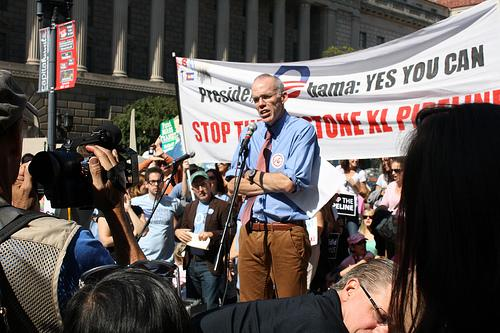Identify the person who is giving a speech and what they are wearing. The man giving a speech is wearing a blue dress shirt, brown pants, a reddish-pink tie, and eyeglasses. What is a noteworthy aspect of the man's body language? The man's body language suggests that he is closed off, maybe nervous or defensive while giving the speech. Discuss any flags or banners present in the image, and their colors. There is a pole with two pennants; one is red, and the other is grey. Additionally, there's a political banner behind the man, which is white with red letters. Describe the scene involving the man campaigning for Obama. There is a man campaigning for Obama, giving a speech, and standing in front of a political banner with a white sign with red letters. The man is wearing glasses, a blue dress shirt, and brown pants. What is the man in the foreground doing, and how is his outfit described? The man in the foreground is giving a speech, and he is wearing eyeglasses, a blue dress shirt with rolled-up sleeves, a reddish-pink tie, brown pants, and a brown belt. Mention the salient features of the building in the background. The large building in the background has lots of columns and appears to be an important or historical venue. List the elements on the pole in the image. Two pennants, one red and the other grey, are hanging on the pole. Develop a title for an article featuring a man giving a speech in front of a crowd at a campaign event. "Electrifying Speech Captivates Audience at Campaign Rally: A Moment to Remember" Identify the color of the tie the man is wearing. Reddishpink Assess the emotion displayed by the man giving the speech. The man appears confident and focused as he speaks. Choose the correct event from the given options: A wedding, A political rally, A sports game. A political rally What is happening in the scene depicted in the image? A man is giving a speech during a campaign event with people surrounding him. Articulate the style of the hat worn by the man in the background. The hat is a green cap with a round, dome-shaped crown and a visor. State the color of the dress shirt worn by the man giving the speech. Blue What is the man doing in the image? The man is giving a speech. Provide a detailed description of the microphone setup used by the man giving the speech. There are two microphones on stands, positioned in front of the man as he speaks. Describe the sunglasses worn by the person in the background. The sunglasses have a rectangular frame and dark lenses. Identify an action the person holding the camera is performing. The person is video taping the speech.   Identify any structures or components presented in the image. There are two pennants on a pole, a campaign sign with red letters on a white background, and a building with lots of columns. Verify any text's presence in the image and provide its details. There is text on a campaign sign, written in red letters on a white background. Read the text on the campaign sign in the image. The campaign sign has red letters on a white background. Create a caption for an image of a man giving a speech at a campaign event with people surrounding him. "Passionate orator delivering a fervent speech to an engaged crowd at a political rally" Describe the attributes of the pants worn by the man giving the speech. The pants are brown and appear to be a part of a suit. Recognize any activity the person wearing sunglasses is participating in. The person wearing sunglasses is watching the man giving the speech. 